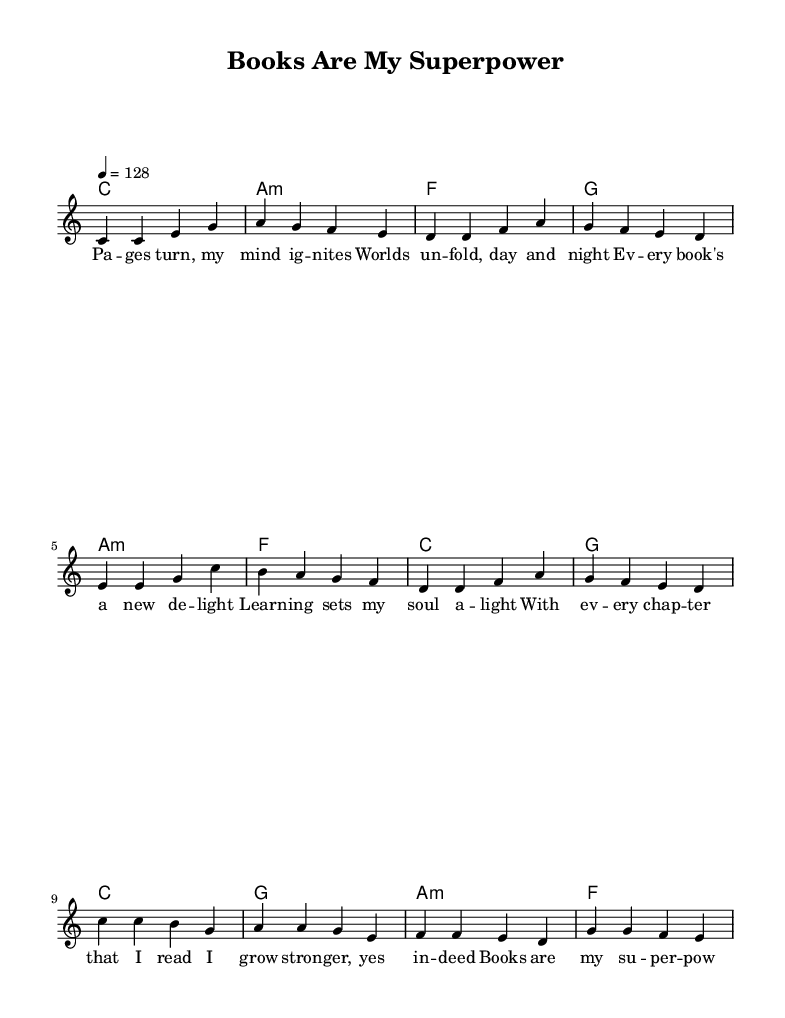What is the key signature of this music? The key signature is C major, which has no sharps or flats.
Answer: C major What is the time signature of this piece? The time signature is 4/4, indicated at the beginning of the staff.
Answer: 4/4 What is the tempo marking for this music? The tempo marking is 4 = 128, which indicates how many beats per minute the piece should be played.
Answer: 128 How many verses are present in the music? The music has one verse section before repeating other parts, identifiable by the lyrics layout but visually confirmed by one set of melodic patterns.
Answer: One What is the repeated musical section in the song called? The section that repeats after the verses is known as the chorus, which is distinctive due to its melodic and lyrical structure.
Answer: Chorus Which harmony follows the pre-chorus? The harmony that comes after the pre-chorus is G major, as indicated in the chord progression chart after the pre-chorus lyrics.
Answer: G What theme does the chorus highlight in the lyrics? The chorus emphasizes empowerment through reading, portraying books as a source of strength and knowledge, reflecting the overall uplifting theme of learning in the music.
Answer: Empowerment through reading 